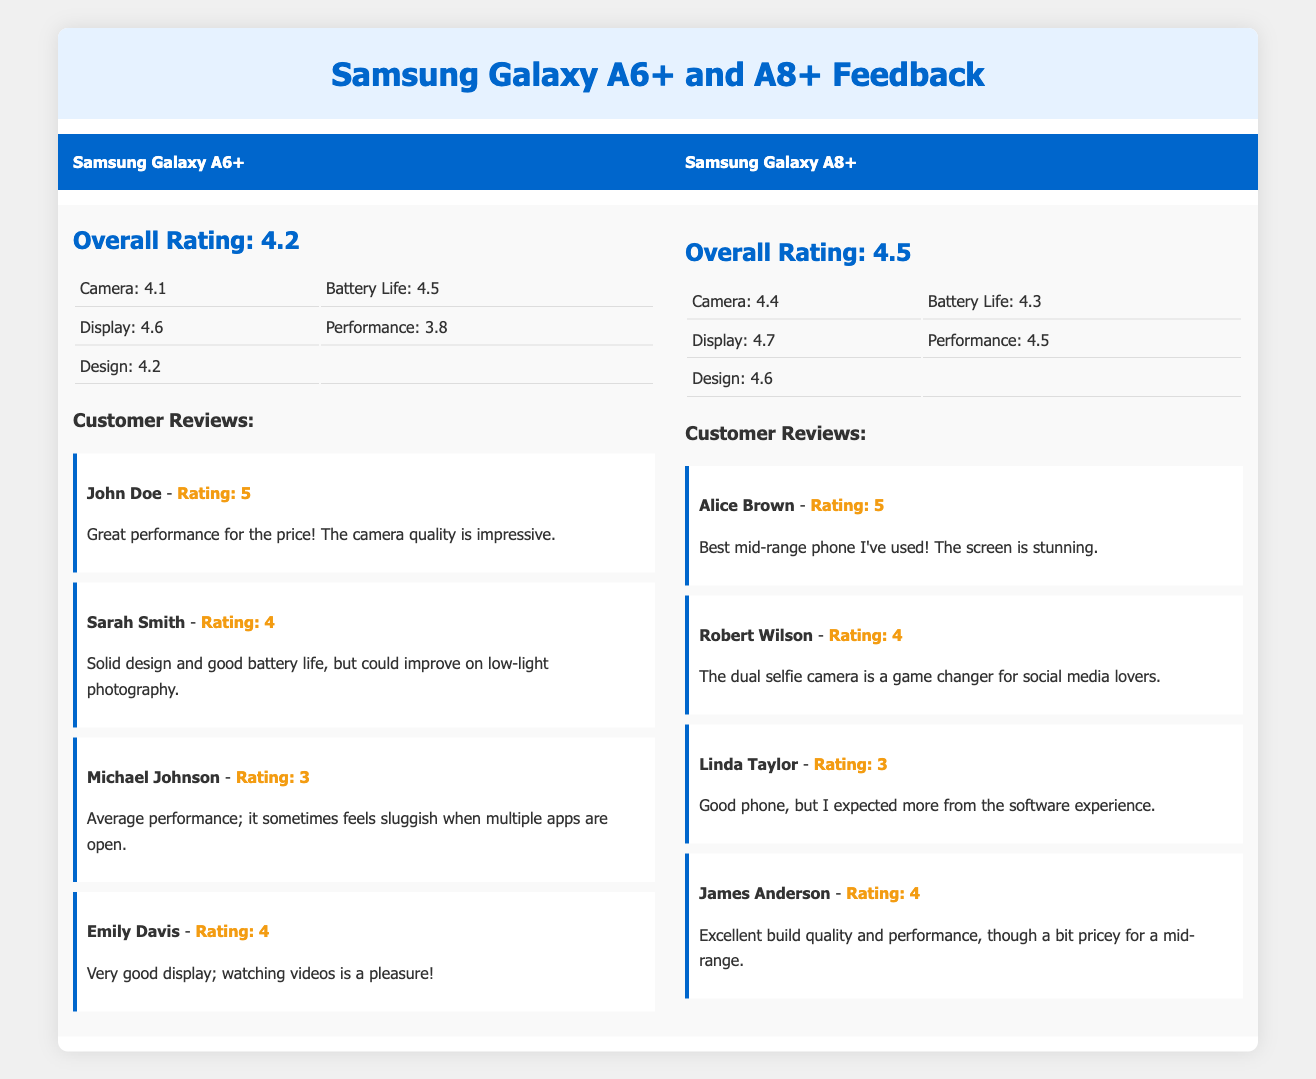What is the overall rating for the Samsung Galaxy A6+? The overall rating for Samsung Galaxy A6+ is provided in the table under the overall rating section, which lists it as 4.2.
Answer: 4.2 What is the camera rating for the Samsung Galaxy A8+? The camera rating for Samsung Galaxy A8+ can be found in the features rating section, listed specifically as 4.4.
Answer: 4.4 Which phone has a better performance rating: Samsung Galaxy A6+ or A8+? To determine this, we compare the performance ratings of both phones; Samsung Galaxy A6+ has a rating of 3.8, while A8+ has a rating of 4.5, indicating A8+ has a better performance rating.
Answer: Samsung Galaxy A8+ Are there more 5-star reviews for Samsung Galaxy A6+ than A8+? Counting the reviews, Samsung Galaxy A6+ has one 5-star review (John Doe), while Samsung Galaxy A8+ also has one 5-star review (Alice Brown). Hence, they have the same number of 5-star reviews, and the answer is no.
Answer: No What is the average rating of the battery life for both phones? To calculate the average, we sum the battery life ratings: A6+ has 4.5 and A8+ has 4.3. The sum is 4.5 + 4.3 = 8.8, and dividing by 2 gives the average of 4.4.
Answer: 4.4 Is the display rating of the Samsung Galaxy A8+ higher than that of the A6+? The display ratings show that the Samsung Galaxy A8+ has a display rating of 4.7 while A6+ has 4.6. Since 4.7 is greater than 4.6, the display rating of A8+ is indeed higher.
Answer: Yes Which reviewer gave the lowest rating to the Samsung Galaxy A6+, and what was their rating? Looking at the customer reviews for Samsung Galaxy A6+, Michael Johnson gave the lowest rating, which is 3.
Answer: Michael Johnson, 3 What is the difference in battery life ratings between the two models? The battery life rating for A6+ is 4.5 and for A8+ it is 4.3. The difference is 4.5 - 4.3 = 0.2.
Answer: 0.2 Does Linda Taylor believe the Samsung Galaxy A8+ has a great software experience? Linda Taylor rated the A8+ 3 and mentioned she expected more from the software experience, which suggests she does not believe it has a great software experience.
Answer: No 